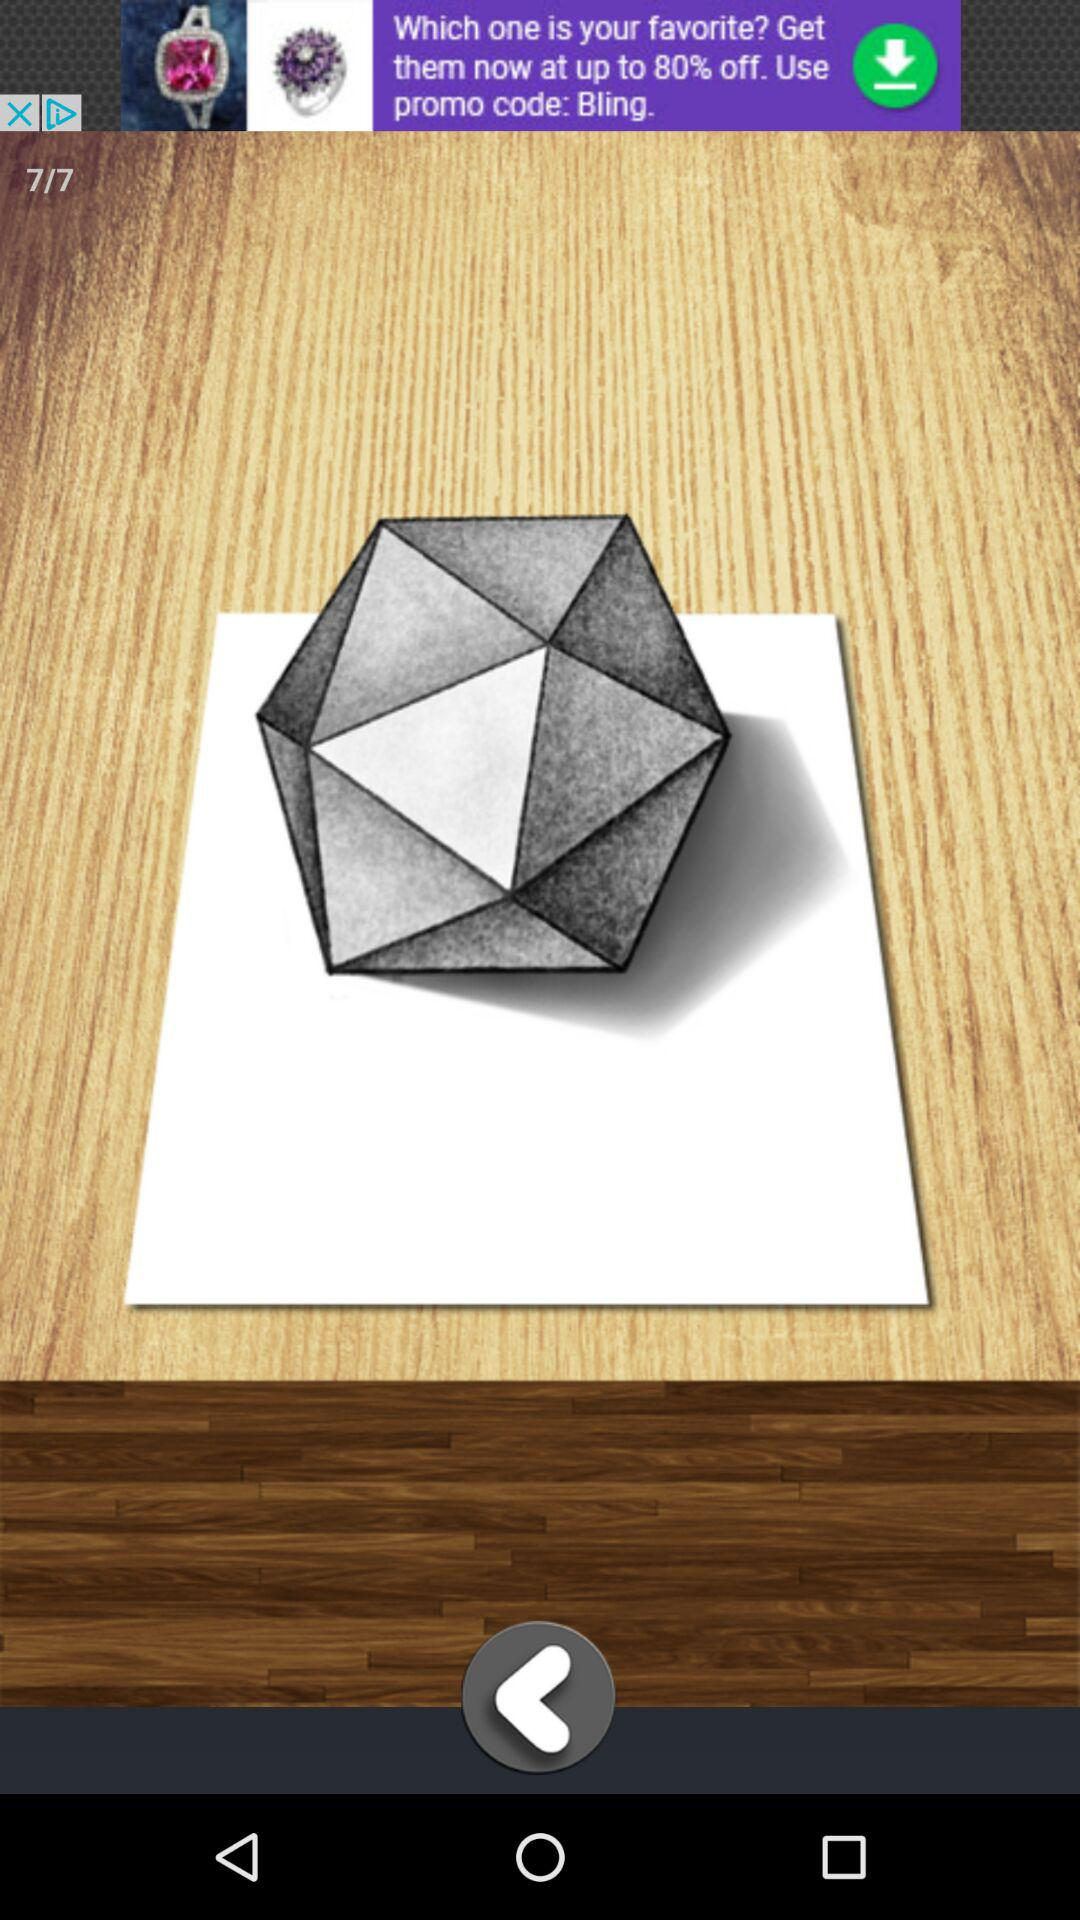What is the number of the current image? The number of the current image is 7. 